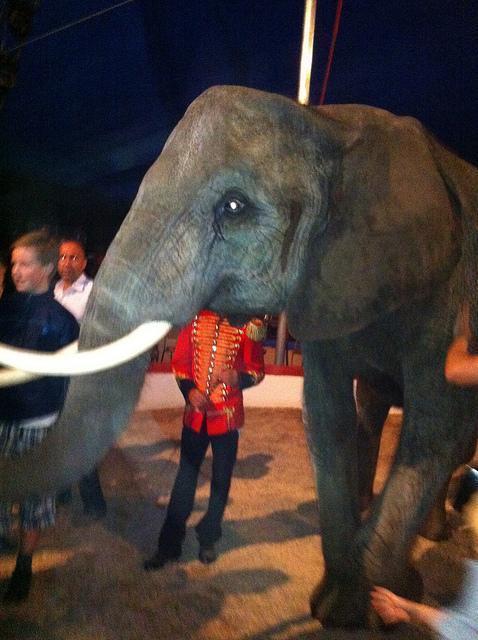What event might this be?
Pick the correct solution from the four options below to address the question.
Options: Circus show, concert, wrestling show, award show. Circus show. 